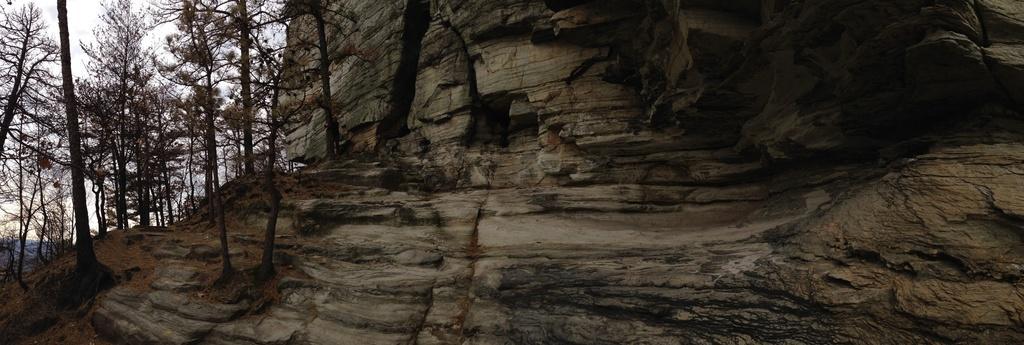How would you summarize this image in a sentence or two? In this picture I can see a hill, there are trees and the sky. 